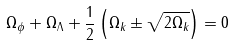<formula> <loc_0><loc_0><loc_500><loc_500>\Omega _ { \phi } + \Omega _ { \Lambda } + \frac { 1 } { 2 } \left ( \Omega _ { k } \pm \sqrt { 2 \Omega _ { k } } \right ) = 0</formula> 